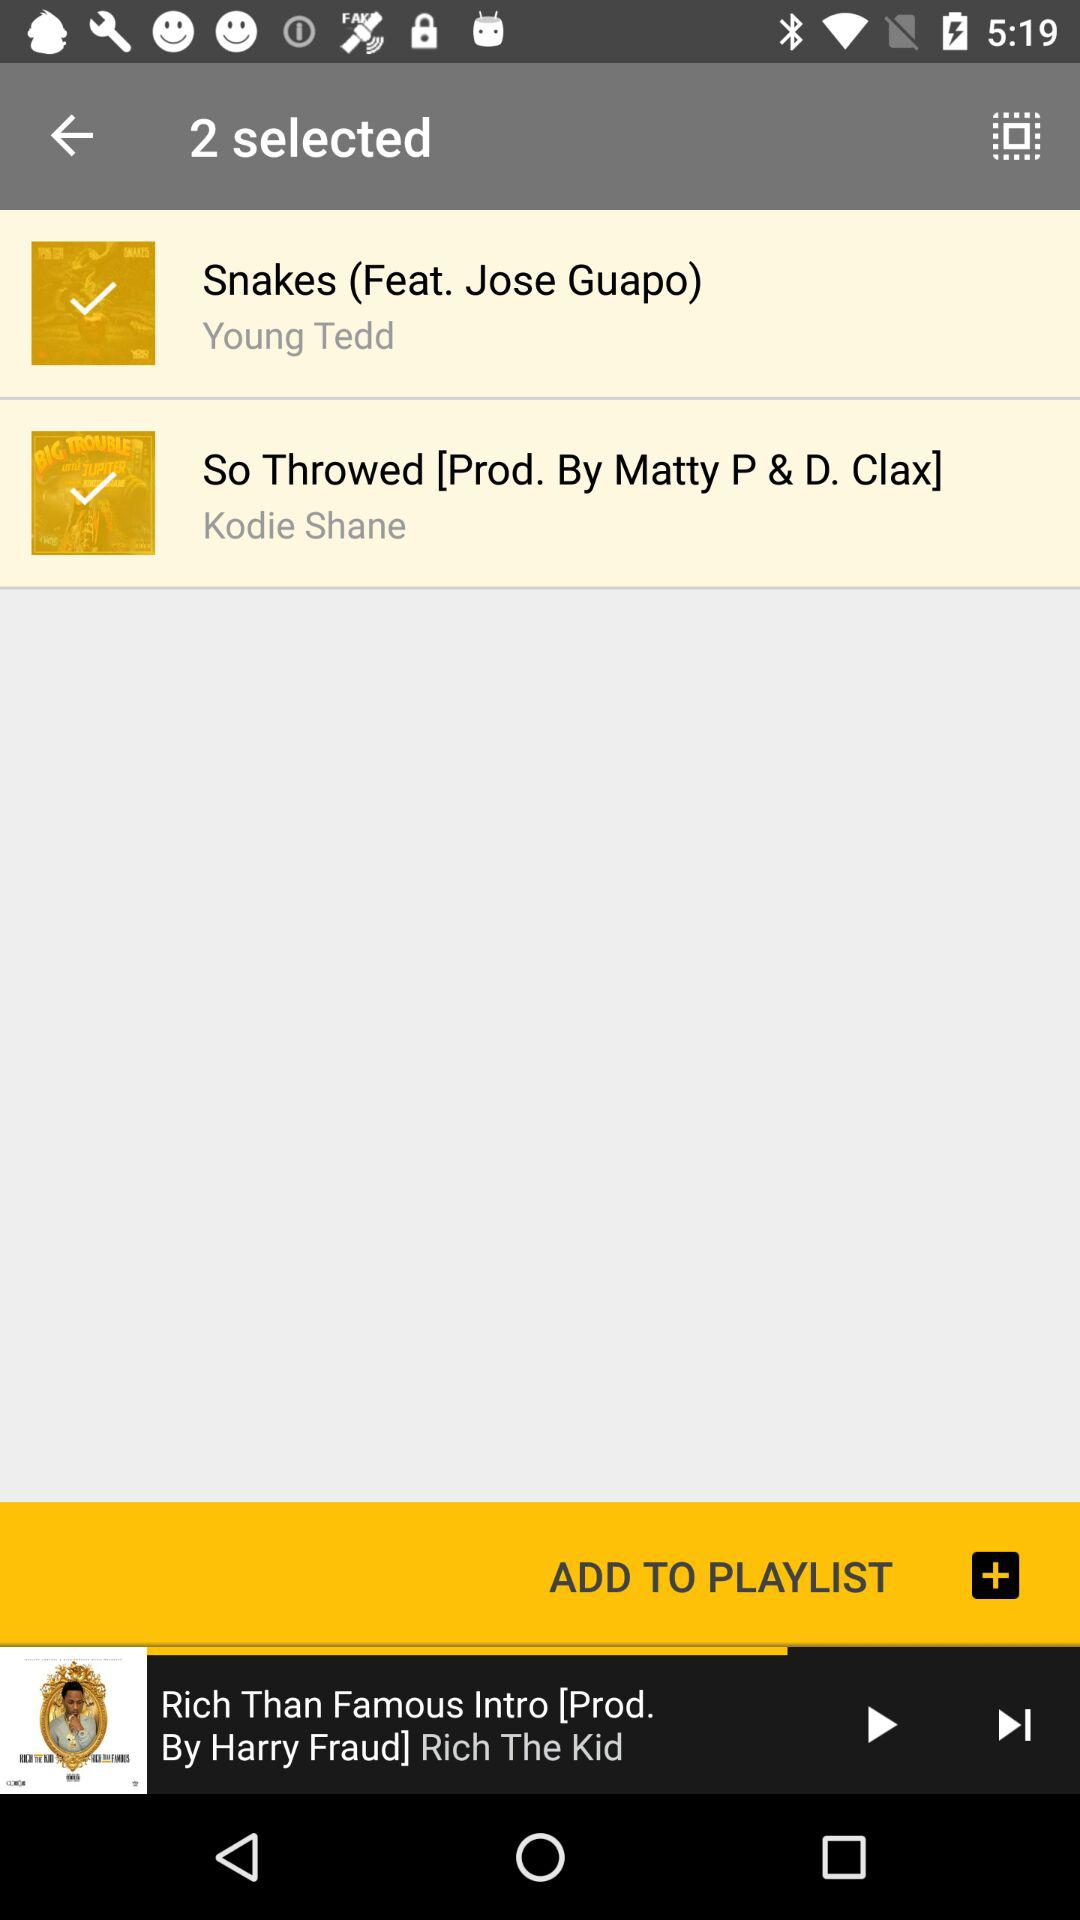Who is the artist of "So Throwed"? The artist is Kodie Shane. 